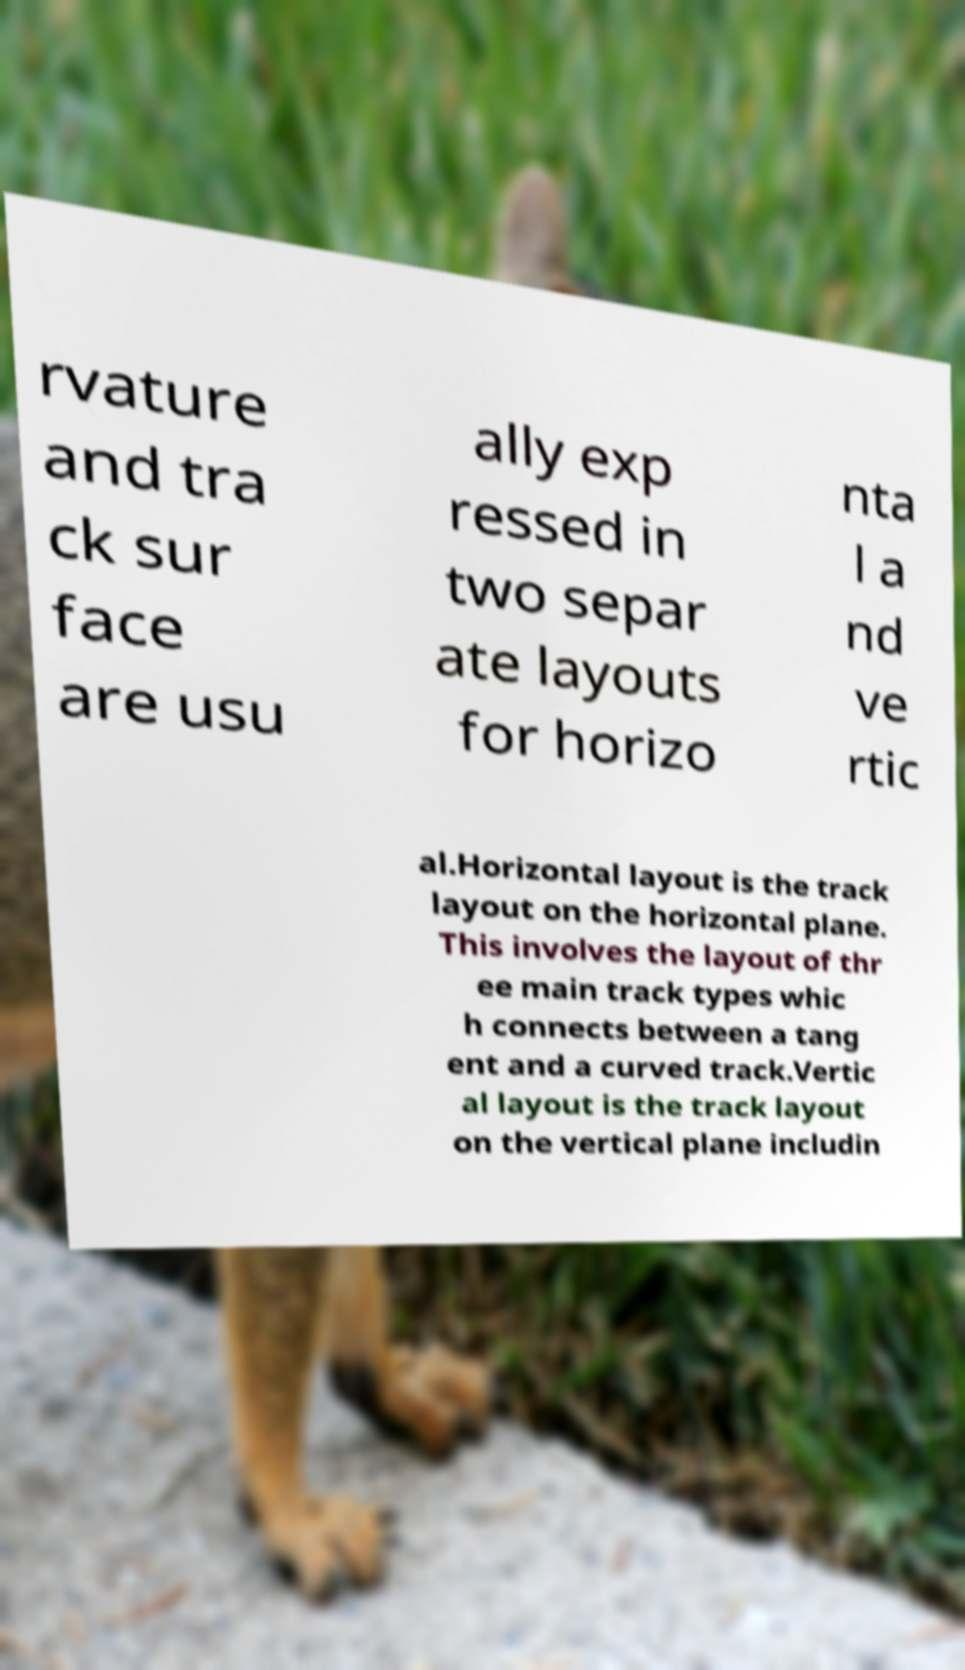Could you extract and type out the text from this image? rvature and tra ck sur face are usu ally exp ressed in two separ ate layouts for horizo nta l a nd ve rtic al.Horizontal layout is the track layout on the horizontal plane. This involves the layout of thr ee main track types whic h connects between a tang ent and a curved track.Vertic al layout is the track layout on the vertical plane includin 